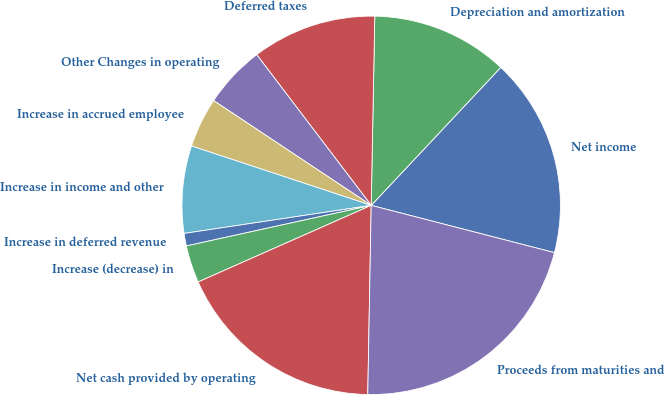Convert chart to OTSL. <chart><loc_0><loc_0><loc_500><loc_500><pie_chart><fcel>Net income<fcel>Depreciation and amortization<fcel>Deferred taxes<fcel>Other Changes in operating<fcel>Increase in accrued employee<fcel>Increase in income and other<fcel>Increase in deferred revenue<fcel>Increase (decrease) in<fcel>Net cash provided by operating<fcel>Proceeds from maturities and<nl><fcel>17.02%<fcel>11.7%<fcel>10.64%<fcel>5.32%<fcel>4.26%<fcel>7.45%<fcel>1.07%<fcel>3.19%<fcel>18.08%<fcel>21.27%<nl></chart> 